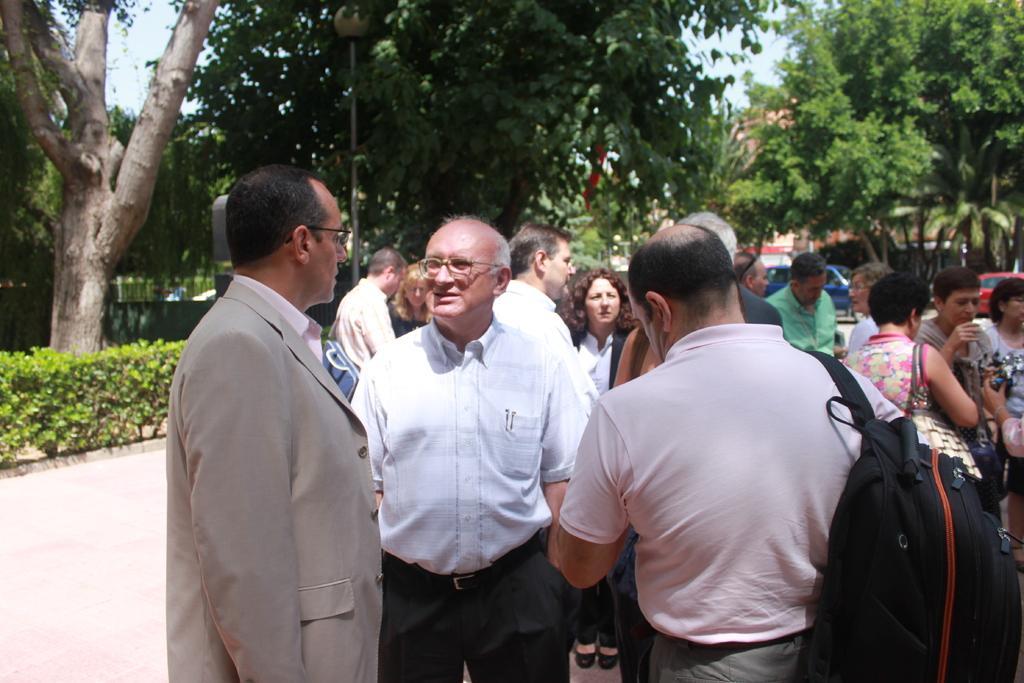Could you give a brief overview of what you see in this image? This is the picture of a place where we have some people, among them some are wearing the backpacks and around there are some trees and plants. 